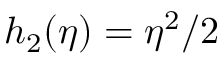<formula> <loc_0><loc_0><loc_500><loc_500>h _ { 2 } ( \eta ) = \eta ^ { 2 } / 2</formula> 